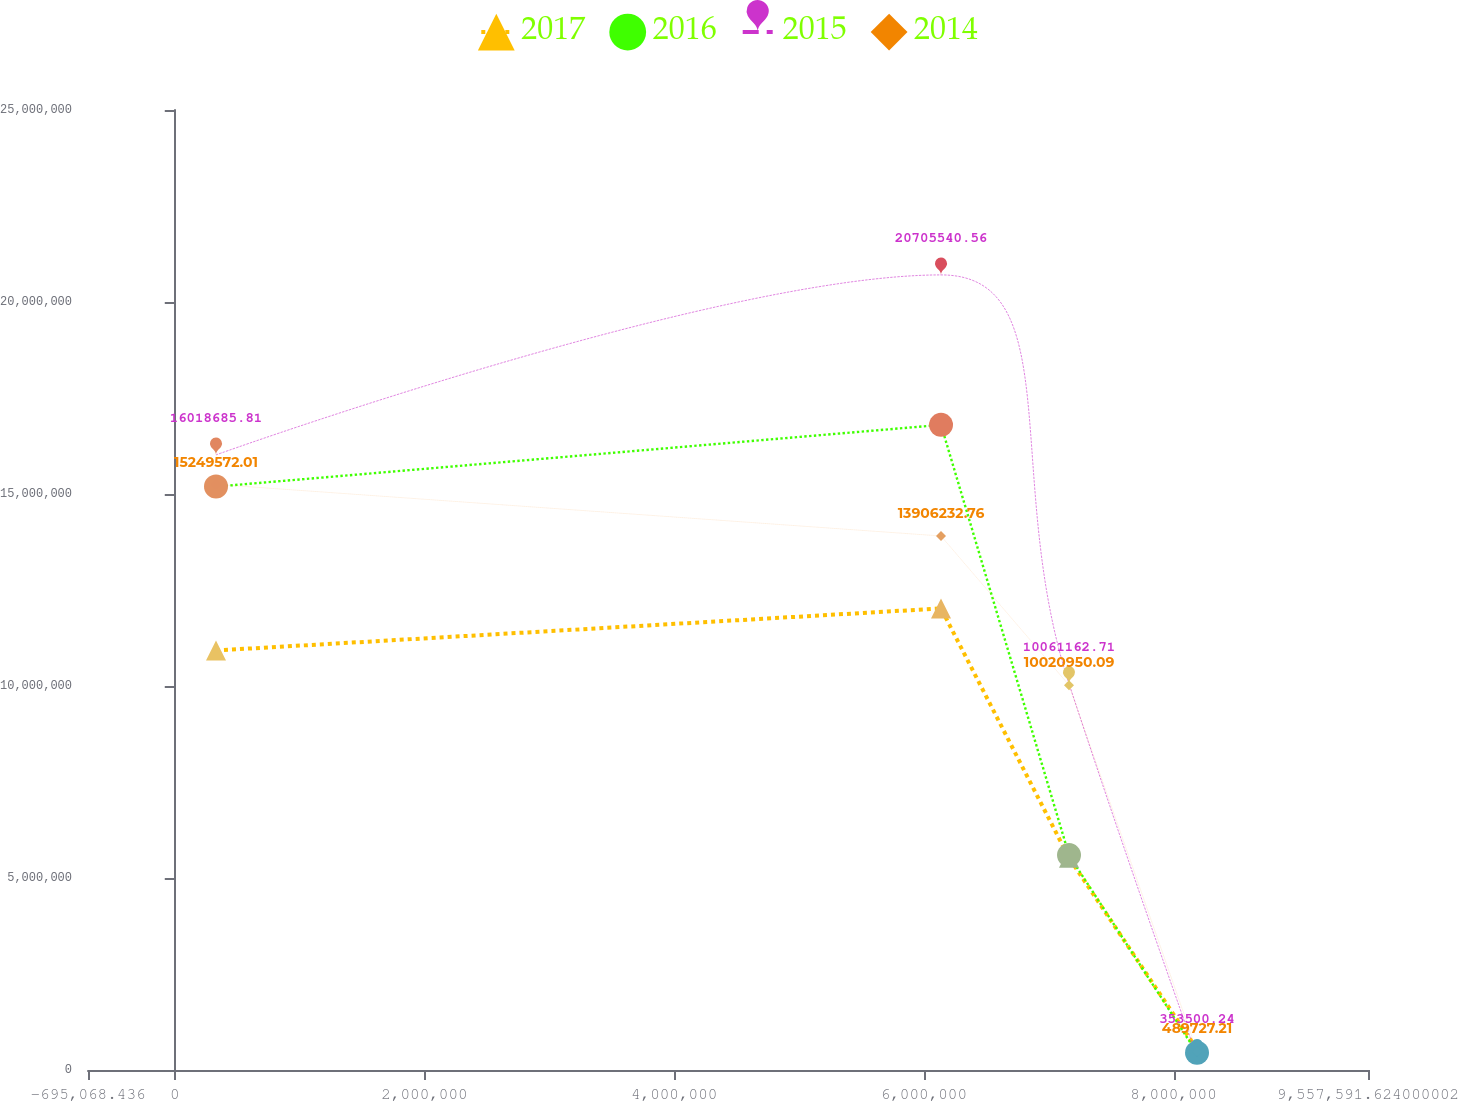Convert chart to OTSL. <chart><loc_0><loc_0><loc_500><loc_500><line_chart><ecel><fcel>2017<fcel>2016<fcel>2015<fcel>2014<nl><fcel>330198<fcel>1.09252e+07<fcel>1.51925e+07<fcel>1.60187e+07<fcel>1.52496e+07<nl><fcel>6.13748e+06<fcel>1.20202e+07<fcel>1.68004e+07<fcel>2.07055e+07<fcel>1.39062e+07<nl><fcel>7.16275e+06<fcel>5.52515e+06<fcel>5.59578e+06<fcel>1.00612e+07<fcel>1.0021e+07<nl><fcel>8.18801e+06<fcel>533771<fcel>447397<fcel>353500<fcel>489727<nl><fcel>1.05829e+07<fcel>6.6202e+06<fcel>7.99966e+06<fcel>7.84343e+06<fcel>8.67761e+06<nl></chart> 